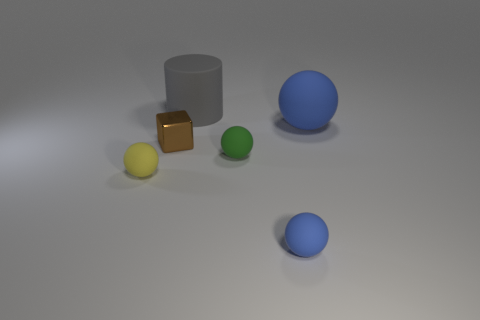Is the size of the blue matte ball behind the yellow sphere the same as the small yellow matte object?
Keep it short and to the point. No. There is a matte object that is on the left side of the small green rubber ball and on the right side of the small brown metallic thing; what size is it?
Give a very brief answer. Large. What number of other things are the same shape as the yellow rubber thing?
Make the answer very short. 3. How many other things are made of the same material as the tiny green ball?
Offer a terse response. 4. There is another blue thing that is the same shape as the small blue object; what is its size?
Keep it short and to the point. Large. There is a small thing that is in front of the small brown object and on the left side of the big gray matte cylinder; what color is it?
Your response must be concise. Yellow. How many objects are blue matte things in front of the yellow ball or metal spheres?
Your answer should be very brief. 1. There is another large matte thing that is the same shape as the yellow object; what color is it?
Your answer should be compact. Blue. There is a shiny object; is its shape the same as the blue thing behind the cube?
Keep it short and to the point. No. What number of objects are either blue spheres in front of the tiny green ball or objects that are left of the green sphere?
Provide a short and direct response. 4. 